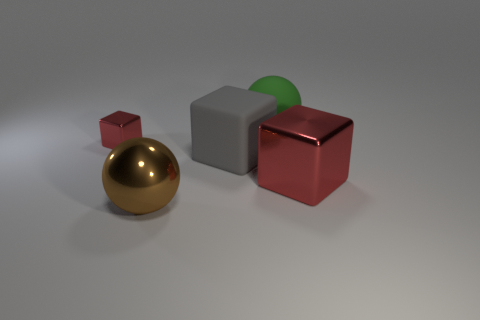How many other objects are there of the same size as the brown metallic thing?
Keep it short and to the point. 3. There is a brown metallic ball; is its size the same as the shiny object that is to the right of the green ball?
Offer a terse response. Yes. What shape is the large object that is in front of the red block that is right of the large block that is behind the big red shiny thing?
Make the answer very short. Sphere. Are there fewer big red objects than yellow shiny cubes?
Make the answer very short. No. Are there any brown balls to the right of the brown metal thing?
Offer a terse response. No. What shape is the thing that is both behind the matte cube and in front of the big green rubber object?
Offer a very short reply. Cube. Are there any other metallic things that have the same shape as the large gray thing?
Keep it short and to the point. Yes. There is a red block to the left of the large gray rubber cube; is it the same size as the metallic object that is on the right side of the matte ball?
Make the answer very short. No. Is the number of big red metallic things greater than the number of large yellow matte blocks?
Keep it short and to the point. Yes. How many other tiny gray objects are the same material as the small thing?
Keep it short and to the point. 0. 